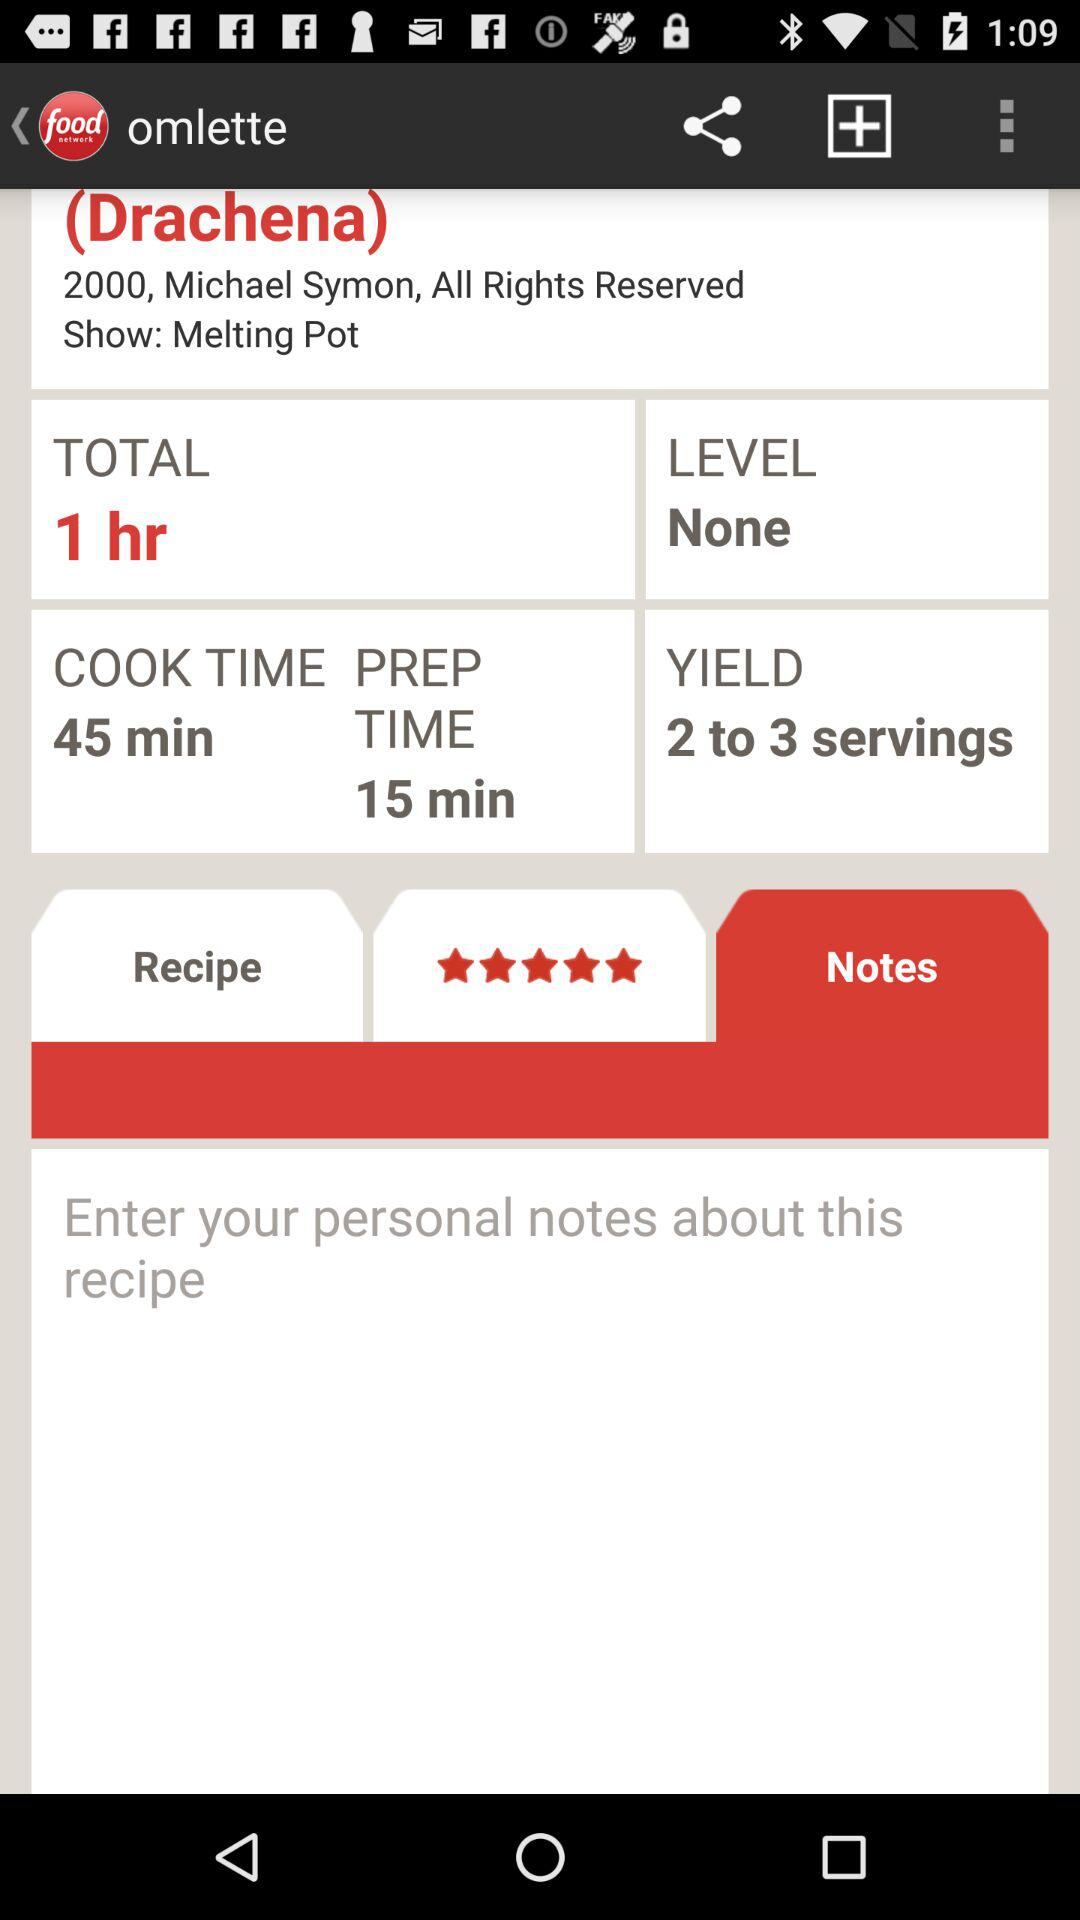Which address is shown?
When the provided information is insufficient, respond with <no answer>. <no answer> 